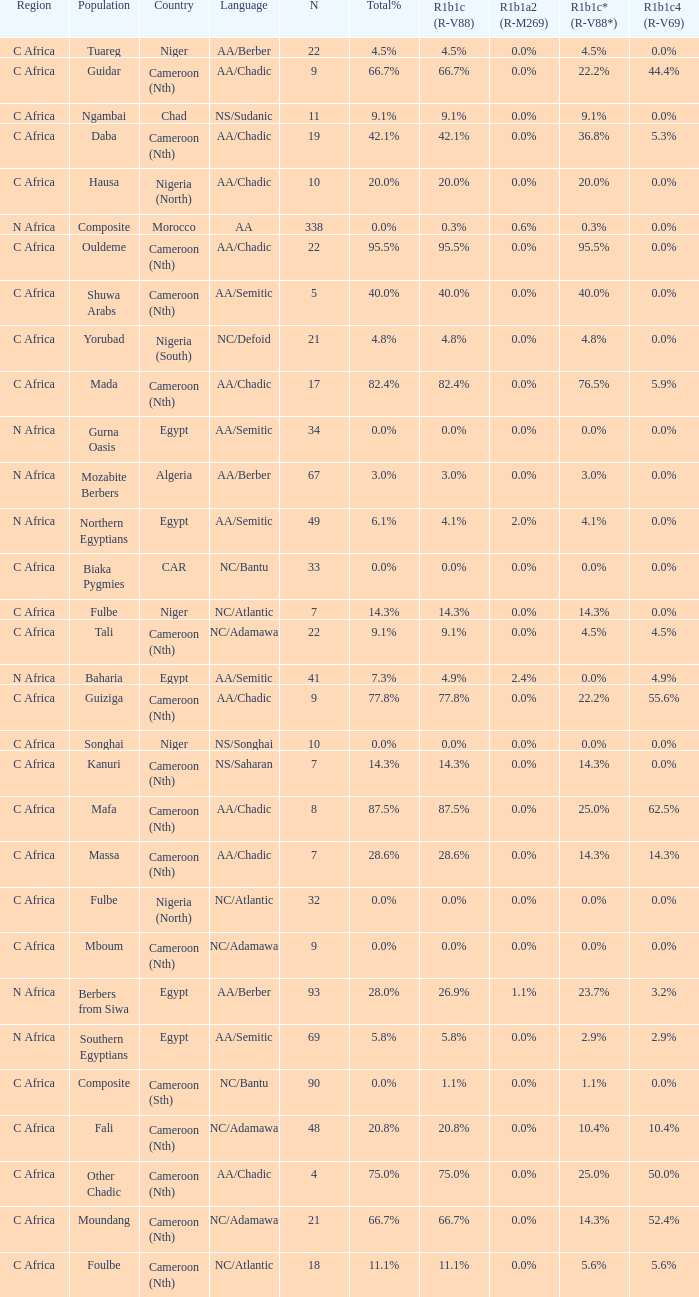How many n are listed for 0.6% r1b1a2 (r-m269)? 1.0. 